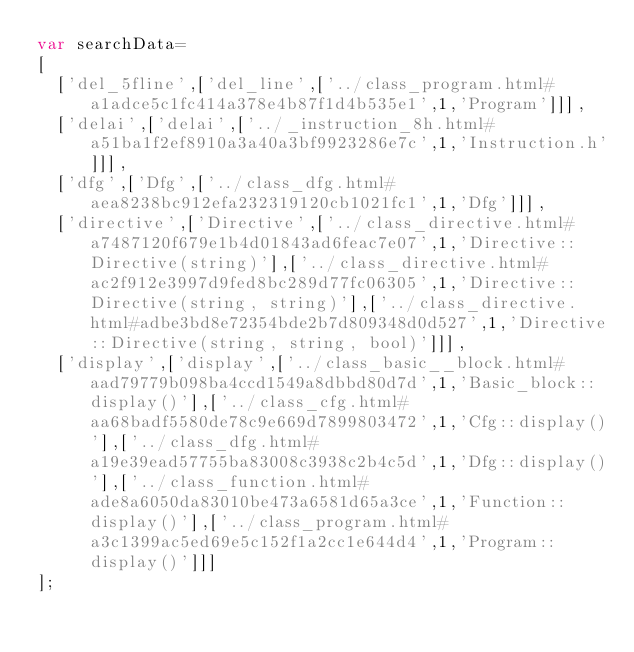Convert code to text. <code><loc_0><loc_0><loc_500><loc_500><_JavaScript_>var searchData=
[
  ['del_5fline',['del_line',['../class_program.html#a1adce5c1fc414a378e4b87f1d4b535e1',1,'Program']]],
  ['delai',['delai',['../_instruction_8h.html#a51ba1f2ef8910a3a40a3bf9923286e7c',1,'Instruction.h']]],
  ['dfg',['Dfg',['../class_dfg.html#aea8238bc912efa232319120cb1021fc1',1,'Dfg']]],
  ['directive',['Directive',['../class_directive.html#a7487120f679e1b4d01843ad6feac7e07',1,'Directive::Directive(string)'],['../class_directive.html#ac2f912e3997d9fed8bc289d77fc06305',1,'Directive::Directive(string, string)'],['../class_directive.html#adbe3bd8e72354bde2b7d809348d0d527',1,'Directive::Directive(string, string, bool)']]],
  ['display',['display',['../class_basic__block.html#aad79779b098ba4ccd1549a8dbbd80d7d',1,'Basic_block::display()'],['../class_cfg.html#aa68badf5580de78c9e669d7899803472',1,'Cfg::display()'],['../class_dfg.html#a19e39ead57755ba83008c3938c2b4c5d',1,'Dfg::display()'],['../class_function.html#ade8a6050da83010be473a6581d65a3ce',1,'Function::display()'],['../class_program.html#a3c1399ac5ed69e5c152f1a2cc1e644d4',1,'Program::display()']]]
];
</code> 